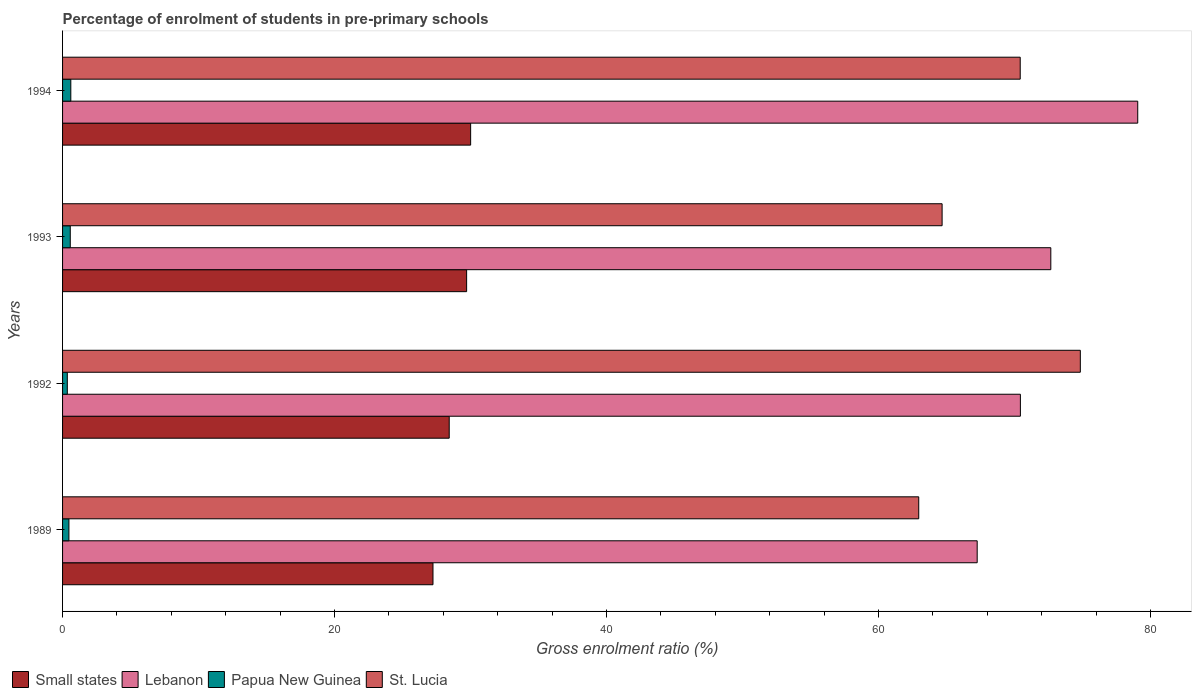How many different coloured bars are there?
Make the answer very short. 4. How many groups of bars are there?
Make the answer very short. 4. What is the label of the 1st group of bars from the top?
Keep it short and to the point. 1994. What is the percentage of students enrolled in pre-primary schools in St. Lucia in 1992?
Provide a short and direct response. 74.84. Across all years, what is the maximum percentage of students enrolled in pre-primary schools in Small states?
Ensure brevity in your answer.  30.01. Across all years, what is the minimum percentage of students enrolled in pre-primary schools in Lebanon?
Your answer should be compact. 67.25. What is the total percentage of students enrolled in pre-primary schools in Lebanon in the graph?
Provide a short and direct response. 289.41. What is the difference between the percentage of students enrolled in pre-primary schools in St. Lucia in 1993 and that in 1994?
Make the answer very short. -5.74. What is the difference between the percentage of students enrolled in pre-primary schools in Papua New Guinea in 1992 and the percentage of students enrolled in pre-primary schools in Lebanon in 1989?
Give a very brief answer. -66.9. What is the average percentage of students enrolled in pre-primary schools in Lebanon per year?
Give a very brief answer. 72.35. In the year 1992, what is the difference between the percentage of students enrolled in pre-primary schools in St. Lucia and percentage of students enrolled in pre-primary schools in Lebanon?
Give a very brief answer. 4.41. What is the ratio of the percentage of students enrolled in pre-primary schools in Small states in 1989 to that in 1993?
Keep it short and to the point. 0.92. Is the percentage of students enrolled in pre-primary schools in Small states in 1989 less than that in 1993?
Ensure brevity in your answer.  Yes. Is the difference between the percentage of students enrolled in pre-primary schools in St. Lucia in 1989 and 1994 greater than the difference between the percentage of students enrolled in pre-primary schools in Lebanon in 1989 and 1994?
Make the answer very short. Yes. What is the difference between the highest and the second highest percentage of students enrolled in pre-primary schools in Small states?
Provide a succinct answer. 0.29. What is the difference between the highest and the lowest percentage of students enrolled in pre-primary schools in Lebanon?
Your response must be concise. 11.81. What does the 4th bar from the top in 1992 represents?
Your answer should be compact. Small states. What does the 2nd bar from the bottom in 1992 represents?
Keep it short and to the point. Lebanon. Are all the bars in the graph horizontal?
Make the answer very short. Yes. Are the values on the major ticks of X-axis written in scientific E-notation?
Your response must be concise. No. How many legend labels are there?
Ensure brevity in your answer.  4. What is the title of the graph?
Keep it short and to the point. Percentage of enrolment of students in pre-primary schools. What is the Gross enrolment ratio (%) of Small states in 1989?
Your answer should be compact. 27.24. What is the Gross enrolment ratio (%) of Lebanon in 1989?
Make the answer very short. 67.25. What is the Gross enrolment ratio (%) of Papua New Guinea in 1989?
Your answer should be very brief. 0.47. What is the Gross enrolment ratio (%) of St. Lucia in 1989?
Offer a terse response. 62.96. What is the Gross enrolment ratio (%) of Small states in 1992?
Offer a terse response. 28.43. What is the Gross enrolment ratio (%) of Lebanon in 1992?
Offer a very short reply. 70.43. What is the Gross enrolment ratio (%) of Papua New Guinea in 1992?
Provide a succinct answer. 0.35. What is the Gross enrolment ratio (%) of St. Lucia in 1992?
Provide a short and direct response. 74.84. What is the Gross enrolment ratio (%) in Small states in 1993?
Offer a terse response. 29.71. What is the Gross enrolment ratio (%) in Lebanon in 1993?
Provide a succinct answer. 72.67. What is the Gross enrolment ratio (%) in Papua New Guinea in 1993?
Make the answer very short. 0.57. What is the Gross enrolment ratio (%) in St. Lucia in 1993?
Make the answer very short. 64.67. What is the Gross enrolment ratio (%) of Small states in 1994?
Keep it short and to the point. 30.01. What is the Gross enrolment ratio (%) of Lebanon in 1994?
Ensure brevity in your answer.  79.06. What is the Gross enrolment ratio (%) in Papua New Guinea in 1994?
Keep it short and to the point. 0.61. What is the Gross enrolment ratio (%) in St. Lucia in 1994?
Offer a terse response. 70.42. Across all years, what is the maximum Gross enrolment ratio (%) of Small states?
Provide a short and direct response. 30.01. Across all years, what is the maximum Gross enrolment ratio (%) in Lebanon?
Offer a very short reply. 79.06. Across all years, what is the maximum Gross enrolment ratio (%) of Papua New Guinea?
Your response must be concise. 0.61. Across all years, what is the maximum Gross enrolment ratio (%) in St. Lucia?
Keep it short and to the point. 74.84. Across all years, what is the minimum Gross enrolment ratio (%) of Small states?
Ensure brevity in your answer.  27.24. Across all years, what is the minimum Gross enrolment ratio (%) of Lebanon?
Ensure brevity in your answer.  67.25. Across all years, what is the minimum Gross enrolment ratio (%) of Papua New Guinea?
Your response must be concise. 0.35. Across all years, what is the minimum Gross enrolment ratio (%) in St. Lucia?
Offer a terse response. 62.96. What is the total Gross enrolment ratio (%) of Small states in the graph?
Give a very brief answer. 115.39. What is the total Gross enrolment ratio (%) of Lebanon in the graph?
Your response must be concise. 289.41. What is the total Gross enrolment ratio (%) of Papua New Guinea in the graph?
Offer a very short reply. 1.99. What is the total Gross enrolment ratio (%) of St. Lucia in the graph?
Offer a terse response. 272.88. What is the difference between the Gross enrolment ratio (%) in Small states in 1989 and that in 1992?
Your answer should be very brief. -1.19. What is the difference between the Gross enrolment ratio (%) in Lebanon in 1989 and that in 1992?
Keep it short and to the point. -3.18. What is the difference between the Gross enrolment ratio (%) of Papua New Guinea in 1989 and that in 1992?
Offer a very short reply. 0.12. What is the difference between the Gross enrolment ratio (%) in St. Lucia in 1989 and that in 1992?
Keep it short and to the point. -11.88. What is the difference between the Gross enrolment ratio (%) in Small states in 1989 and that in 1993?
Your answer should be very brief. -2.47. What is the difference between the Gross enrolment ratio (%) of Lebanon in 1989 and that in 1993?
Give a very brief answer. -5.41. What is the difference between the Gross enrolment ratio (%) of Papua New Guinea in 1989 and that in 1993?
Offer a very short reply. -0.1. What is the difference between the Gross enrolment ratio (%) of St. Lucia in 1989 and that in 1993?
Ensure brevity in your answer.  -1.72. What is the difference between the Gross enrolment ratio (%) in Small states in 1989 and that in 1994?
Make the answer very short. -2.77. What is the difference between the Gross enrolment ratio (%) in Lebanon in 1989 and that in 1994?
Keep it short and to the point. -11.81. What is the difference between the Gross enrolment ratio (%) in Papua New Guinea in 1989 and that in 1994?
Your answer should be very brief. -0.14. What is the difference between the Gross enrolment ratio (%) of St. Lucia in 1989 and that in 1994?
Make the answer very short. -7.46. What is the difference between the Gross enrolment ratio (%) in Small states in 1992 and that in 1993?
Make the answer very short. -1.28. What is the difference between the Gross enrolment ratio (%) of Lebanon in 1992 and that in 1993?
Keep it short and to the point. -2.24. What is the difference between the Gross enrolment ratio (%) in Papua New Guinea in 1992 and that in 1993?
Your answer should be very brief. -0.22. What is the difference between the Gross enrolment ratio (%) in St. Lucia in 1992 and that in 1993?
Offer a terse response. 10.16. What is the difference between the Gross enrolment ratio (%) of Small states in 1992 and that in 1994?
Provide a succinct answer. -1.57. What is the difference between the Gross enrolment ratio (%) in Lebanon in 1992 and that in 1994?
Offer a terse response. -8.63. What is the difference between the Gross enrolment ratio (%) in Papua New Guinea in 1992 and that in 1994?
Ensure brevity in your answer.  -0.26. What is the difference between the Gross enrolment ratio (%) of St. Lucia in 1992 and that in 1994?
Your answer should be compact. 4.42. What is the difference between the Gross enrolment ratio (%) in Small states in 1993 and that in 1994?
Provide a succinct answer. -0.29. What is the difference between the Gross enrolment ratio (%) of Lebanon in 1993 and that in 1994?
Ensure brevity in your answer.  -6.39. What is the difference between the Gross enrolment ratio (%) in Papua New Guinea in 1993 and that in 1994?
Give a very brief answer. -0.04. What is the difference between the Gross enrolment ratio (%) in St. Lucia in 1993 and that in 1994?
Ensure brevity in your answer.  -5.74. What is the difference between the Gross enrolment ratio (%) of Small states in 1989 and the Gross enrolment ratio (%) of Lebanon in 1992?
Provide a succinct answer. -43.19. What is the difference between the Gross enrolment ratio (%) in Small states in 1989 and the Gross enrolment ratio (%) in Papua New Guinea in 1992?
Your response must be concise. 26.89. What is the difference between the Gross enrolment ratio (%) of Small states in 1989 and the Gross enrolment ratio (%) of St. Lucia in 1992?
Your answer should be compact. -47.6. What is the difference between the Gross enrolment ratio (%) of Lebanon in 1989 and the Gross enrolment ratio (%) of Papua New Guinea in 1992?
Make the answer very short. 66.9. What is the difference between the Gross enrolment ratio (%) in Lebanon in 1989 and the Gross enrolment ratio (%) in St. Lucia in 1992?
Ensure brevity in your answer.  -7.58. What is the difference between the Gross enrolment ratio (%) of Papua New Guinea in 1989 and the Gross enrolment ratio (%) of St. Lucia in 1992?
Provide a short and direct response. -74.37. What is the difference between the Gross enrolment ratio (%) in Small states in 1989 and the Gross enrolment ratio (%) in Lebanon in 1993?
Provide a short and direct response. -45.43. What is the difference between the Gross enrolment ratio (%) in Small states in 1989 and the Gross enrolment ratio (%) in Papua New Guinea in 1993?
Give a very brief answer. 26.67. What is the difference between the Gross enrolment ratio (%) of Small states in 1989 and the Gross enrolment ratio (%) of St. Lucia in 1993?
Offer a terse response. -37.44. What is the difference between the Gross enrolment ratio (%) of Lebanon in 1989 and the Gross enrolment ratio (%) of Papua New Guinea in 1993?
Give a very brief answer. 66.69. What is the difference between the Gross enrolment ratio (%) in Lebanon in 1989 and the Gross enrolment ratio (%) in St. Lucia in 1993?
Ensure brevity in your answer.  2.58. What is the difference between the Gross enrolment ratio (%) of Papua New Guinea in 1989 and the Gross enrolment ratio (%) of St. Lucia in 1993?
Offer a very short reply. -64.21. What is the difference between the Gross enrolment ratio (%) in Small states in 1989 and the Gross enrolment ratio (%) in Lebanon in 1994?
Offer a very short reply. -51.82. What is the difference between the Gross enrolment ratio (%) in Small states in 1989 and the Gross enrolment ratio (%) in Papua New Guinea in 1994?
Make the answer very short. 26.63. What is the difference between the Gross enrolment ratio (%) in Small states in 1989 and the Gross enrolment ratio (%) in St. Lucia in 1994?
Keep it short and to the point. -43.18. What is the difference between the Gross enrolment ratio (%) in Lebanon in 1989 and the Gross enrolment ratio (%) in Papua New Guinea in 1994?
Keep it short and to the point. 66.65. What is the difference between the Gross enrolment ratio (%) of Lebanon in 1989 and the Gross enrolment ratio (%) of St. Lucia in 1994?
Give a very brief answer. -3.16. What is the difference between the Gross enrolment ratio (%) in Papua New Guinea in 1989 and the Gross enrolment ratio (%) in St. Lucia in 1994?
Your response must be concise. -69.95. What is the difference between the Gross enrolment ratio (%) in Small states in 1992 and the Gross enrolment ratio (%) in Lebanon in 1993?
Provide a succinct answer. -44.24. What is the difference between the Gross enrolment ratio (%) of Small states in 1992 and the Gross enrolment ratio (%) of Papua New Guinea in 1993?
Your answer should be compact. 27.87. What is the difference between the Gross enrolment ratio (%) of Small states in 1992 and the Gross enrolment ratio (%) of St. Lucia in 1993?
Ensure brevity in your answer.  -36.24. What is the difference between the Gross enrolment ratio (%) of Lebanon in 1992 and the Gross enrolment ratio (%) of Papua New Guinea in 1993?
Provide a short and direct response. 69.86. What is the difference between the Gross enrolment ratio (%) of Lebanon in 1992 and the Gross enrolment ratio (%) of St. Lucia in 1993?
Offer a very short reply. 5.76. What is the difference between the Gross enrolment ratio (%) in Papua New Guinea in 1992 and the Gross enrolment ratio (%) in St. Lucia in 1993?
Provide a succinct answer. -64.33. What is the difference between the Gross enrolment ratio (%) of Small states in 1992 and the Gross enrolment ratio (%) of Lebanon in 1994?
Make the answer very short. -50.63. What is the difference between the Gross enrolment ratio (%) in Small states in 1992 and the Gross enrolment ratio (%) in Papua New Guinea in 1994?
Give a very brief answer. 27.82. What is the difference between the Gross enrolment ratio (%) of Small states in 1992 and the Gross enrolment ratio (%) of St. Lucia in 1994?
Offer a very short reply. -41.99. What is the difference between the Gross enrolment ratio (%) in Lebanon in 1992 and the Gross enrolment ratio (%) in Papua New Guinea in 1994?
Your response must be concise. 69.82. What is the difference between the Gross enrolment ratio (%) in Lebanon in 1992 and the Gross enrolment ratio (%) in St. Lucia in 1994?
Make the answer very short. 0.01. What is the difference between the Gross enrolment ratio (%) of Papua New Guinea in 1992 and the Gross enrolment ratio (%) of St. Lucia in 1994?
Your response must be concise. -70.07. What is the difference between the Gross enrolment ratio (%) in Small states in 1993 and the Gross enrolment ratio (%) in Lebanon in 1994?
Your response must be concise. -49.35. What is the difference between the Gross enrolment ratio (%) of Small states in 1993 and the Gross enrolment ratio (%) of Papua New Guinea in 1994?
Offer a terse response. 29.1. What is the difference between the Gross enrolment ratio (%) of Small states in 1993 and the Gross enrolment ratio (%) of St. Lucia in 1994?
Your answer should be very brief. -40.71. What is the difference between the Gross enrolment ratio (%) in Lebanon in 1993 and the Gross enrolment ratio (%) in Papua New Guinea in 1994?
Provide a succinct answer. 72.06. What is the difference between the Gross enrolment ratio (%) in Lebanon in 1993 and the Gross enrolment ratio (%) in St. Lucia in 1994?
Offer a very short reply. 2.25. What is the difference between the Gross enrolment ratio (%) of Papua New Guinea in 1993 and the Gross enrolment ratio (%) of St. Lucia in 1994?
Ensure brevity in your answer.  -69.85. What is the average Gross enrolment ratio (%) in Small states per year?
Your answer should be compact. 28.85. What is the average Gross enrolment ratio (%) in Lebanon per year?
Offer a terse response. 72.35. What is the average Gross enrolment ratio (%) in Papua New Guinea per year?
Provide a short and direct response. 0.5. What is the average Gross enrolment ratio (%) of St. Lucia per year?
Make the answer very short. 68.22. In the year 1989, what is the difference between the Gross enrolment ratio (%) in Small states and Gross enrolment ratio (%) in Lebanon?
Give a very brief answer. -40.02. In the year 1989, what is the difference between the Gross enrolment ratio (%) of Small states and Gross enrolment ratio (%) of Papua New Guinea?
Ensure brevity in your answer.  26.77. In the year 1989, what is the difference between the Gross enrolment ratio (%) in Small states and Gross enrolment ratio (%) in St. Lucia?
Your response must be concise. -35.72. In the year 1989, what is the difference between the Gross enrolment ratio (%) in Lebanon and Gross enrolment ratio (%) in Papua New Guinea?
Provide a succinct answer. 66.79. In the year 1989, what is the difference between the Gross enrolment ratio (%) of Lebanon and Gross enrolment ratio (%) of St. Lucia?
Provide a succinct answer. 4.3. In the year 1989, what is the difference between the Gross enrolment ratio (%) of Papua New Guinea and Gross enrolment ratio (%) of St. Lucia?
Offer a very short reply. -62.49. In the year 1992, what is the difference between the Gross enrolment ratio (%) of Small states and Gross enrolment ratio (%) of Lebanon?
Your answer should be very brief. -42. In the year 1992, what is the difference between the Gross enrolment ratio (%) in Small states and Gross enrolment ratio (%) in Papua New Guinea?
Ensure brevity in your answer.  28.08. In the year 1992, what is the difference between the Gross enrolment ratio (%) in Small states and Gross enrolment ratio (%) in St. Lucia?
Provide a short and direct response. -46.41. In the year 1992, what is the difference between the Gross enrolment ratio (%) in Lebanon and Gross enrolment ratio (%) in Papua New Guinea?
Keep it short and to the point. 70.08. In the year 1992, what is the difference between the Gross enrolment ratio (%) of Lebanon and Gross enrolment ratio (%) of St. Lucia?
Give a very brief answer. -4.41. In the year 1992, what is the difference between the Gross enrolment ratio (%) of Papua New Guinea and Gross enrolment ratio (%) of St. Lucia?
Provide a succinct answer. -74.49. In the year 1993, what is the difference between the Gross enrolment ratio (%) in Small states and Gross enrolment ratio (%) in Lebanon?
Your answer should be very brief. -42.96. In the year 1993, what is the difference between the Gross enrolment ratio (%) of Small states and Gross enrolment ratio (%) of Papua New Guinea?
Offer a very short reply. 29.15. In the year 1993, what is the difference between the Gross enrolment ratio (%) in Small states and Gross enrolment ratio (%) in St. Lucia?
Your response must be concise. -34.96. In the year 1993, what is the difference between the Gross enrolment ratio (%) in Lebanon and Gross enrolment ratio (%) in Papua New Guinea?
Your answer should be compact. 72.1. In the year 1993, what is the difference between the Gross enrolment ratio (%) in Lebanon and Gross enrolment ratio (%) in St. Lucia?
Your answer should be very brief. 7.99. In the year 1993, what is the difference between the Gross enrolment ratio (%) of Papua New Guinea and Gross enrolment ratio (%) of St. Lucia?
Your response must be concise. -64.11. In the year 1994, what is the difference between the Gross enrolment ratio (%) of Small states and Gross enrolment ratio (%) of Lebanon?
Offer a terse response. -49.05. In the year 1994, what is the difference between the Gross enrolment ratio (%) in Small states and Gross enrolment ratio (%) in Papua New Guinea?
Your response must be concise. 29.4. In the year 1994, what is the difference between the Gross enrolment ratio (%) of Small states and Gross enrolment ratio (%) of St. Lucia?
Give a very brief answer. -40.41. In the year 1994, what is the difference between the Gross enrolment ratio (%) of Lebanon and Gross enrolment ratio (%) of Papua New Guinea?
Your response must be concise. 78.45. In the year 1994, what is the difference between the Gross enrolment ratio (%) in Lebanon and Gross enrolment ratio (%) in St. Lucia?
Ensure brevity in your answer.  8.64. In the year 1994, what is the difference between the Gross enrolment ratio (%) in Papua New Guinea and Gross enrolment ratio (%) in St. Lucia?
Your response must be concise. -69.81. What is the ratio of the Gross enrolment ratio (%) of Small states in 1989 to that in 1992?
Offer a terse response. 0.96. What is the ratio of the Gross enrolment ratio (%) of Lebanon in 1989 to that in 1992?
Provide a succinct answer. 0.95. What is the ratio of the Gross enrolment ratio (%) of Papua New Guinea in 1989 to that in 1992?
Provide a succinct answer. 1.34. What is the ratio of the Gross enrolment ratio (%) of St. Lucia in 1989 to that in 1992?
Your answer should be compact. 0.84. What is the ratio of the Gross enrolment ratio (%) of Small states in 1989 to that in 1993?
Your response must be concise. 0.92. What is the ratio of the Gross enrolment ratio (%) in Lebanon in 1989 to that in 1993?
Ensure brevity in your answer.  0.93. What is the ratio of the Gross enrolment ratio (%) of Papua New Guinea in 1989 to that in 1993?
Provide a succinct answer. 0.83. What is the ratio of the Gross enrolment ratio (%) of St. Lucia in 1989 to that in 1993?
Your response must be concise. 0.97. What is the ratio of the Gross enrolment ratio (%) of Small states in 1989 to that in 1994?
Provide a short and direct response. 0.91. What is the ratio of the Gross enrolment ratio (%) in Lebanon in 1989 to that in 1994?
Provide a short and direct response. 0.85. What is the ratio of the Gross enrolment ratio (%) of Papua New Guinea in 1989 to that in 1994?
Offer a very short reply. 0.77. What is the ratio of the Gross enrolment ratio (%) in St. Lucia in 1989 to that in 1994?
Provide a succinct answer. 0.89. What is the ratio of the Gross enrolment ratio (%) of Small states in 1992 to that in 1993?
Give a very brief answer. 0.96. What is the ratio of the Gross enrolment ratio (%) in Lebanon in 1992 to that in 1993?
Offer a terse response. 0.97. What is the ratio of the Gross enrolment ratio (%) of Papua New Guinea in 1992 to that in 1993?
Your response must be concise. 0.62. What is the ratio of the Gross enrolment ratio (%) of St. Lucia in 1992 to that in 1993?
Offer a very short reply. 1.16. What is the ratio of the Gross enrolment ratio (%) in Small states in 1992 to that in 1994?
Provide a succinct answer. 0.95. What is the ratio of the Gross enrolment ratio (%) in Lebanon in 1992 to that in 1994?
Your answer should be very brief. 0.89. What is the ratio of the Gross enrolment ratio (%) in Papua New Guinea in 1992 to that in 1994?
Your response must be concise. 0.57. What is the ratio of the Gross enrolment ratio (%) in St. Lucia in 1992 to that in 1994?
Your answer should be compact. 1.06. What is the ratio of the Gross enrolment ratio (%) in Small states in 1993 to that in 1994?
Make the answer very short. 0.99. What is the ratio of the Gross enrolment ratio (%) in Lebanon in 1993 to that in 1994?
Offer a terse response. 0.92. What is the ratio of the Gross enrolment ratio (%) of Papua New Guinea in 1993 to that in 1994?
Provide a short and direct response. 0.93. What is the ratio of the Gross enrolment ratio (%) in St. Lucia in 1993 to that in 1994?
Provide a short and direct response. 0.92. What is the difference between the highest and the second highest Gross enrolment ratio (%) of Small states?
Your response must be concise. 0.29. What is the difference between the highest and the second highest Gross enrolment ratio (%) in Lebanon?
Provide a succinct answer. 6.39. What is the difference between the highest and the second highest Gross enrolment ratio (%) in Papua New Guinea?
Your answer should be compact. 0.04. What is the difference between the highest and the second highest Gross enrolment ratio (%) of St. Lucia?
Your answer should be very brief. 4.42. What is the difference between the highest and the lowest Gross enrolment ratio (%) in Small states?
Provide a short and direct response. 2.77. What is the difference between the highest and the lowest Gross enrolment ratio (%) in Lebanon?
Your answer should be compact. 11.81. What is the difference between the highest and the lowest Gross enrolment ratio (%) of Papua New Guinea?
Offer a very short reply. 0.26. What is the difference between the highest and the lowest Gross enrolment ratio (%) of St. Lucia?
Ensure brevity in your answer.  11.88. 